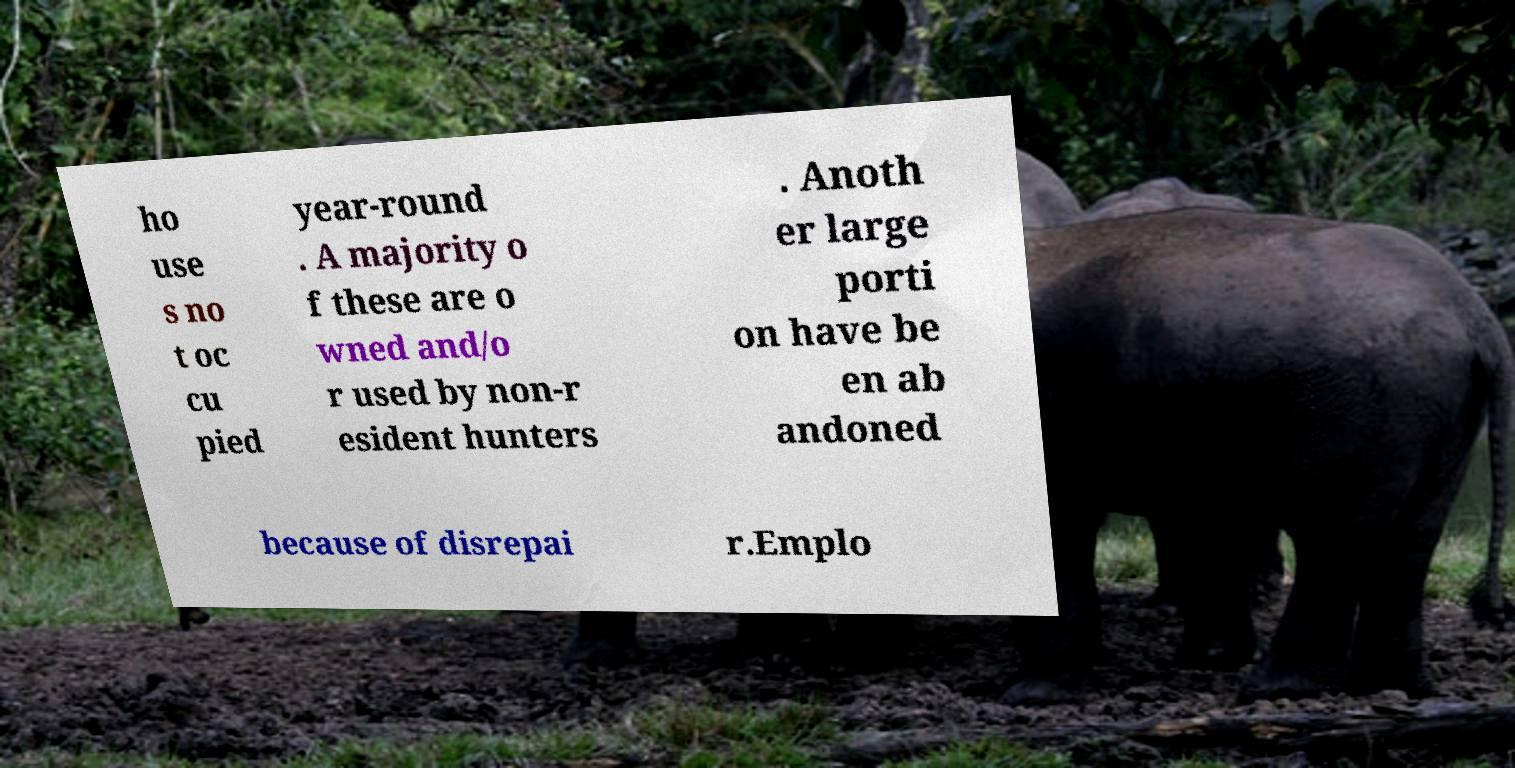What messages or text are displayed in this image? I need them in a readable, typed format. ho use s no t oc cu pied year-round . A majority o f these are o wned and/o r used by non-r esident hunters . Anoth er large porti on have be en ab andoned because of disrepai r.Emplo 